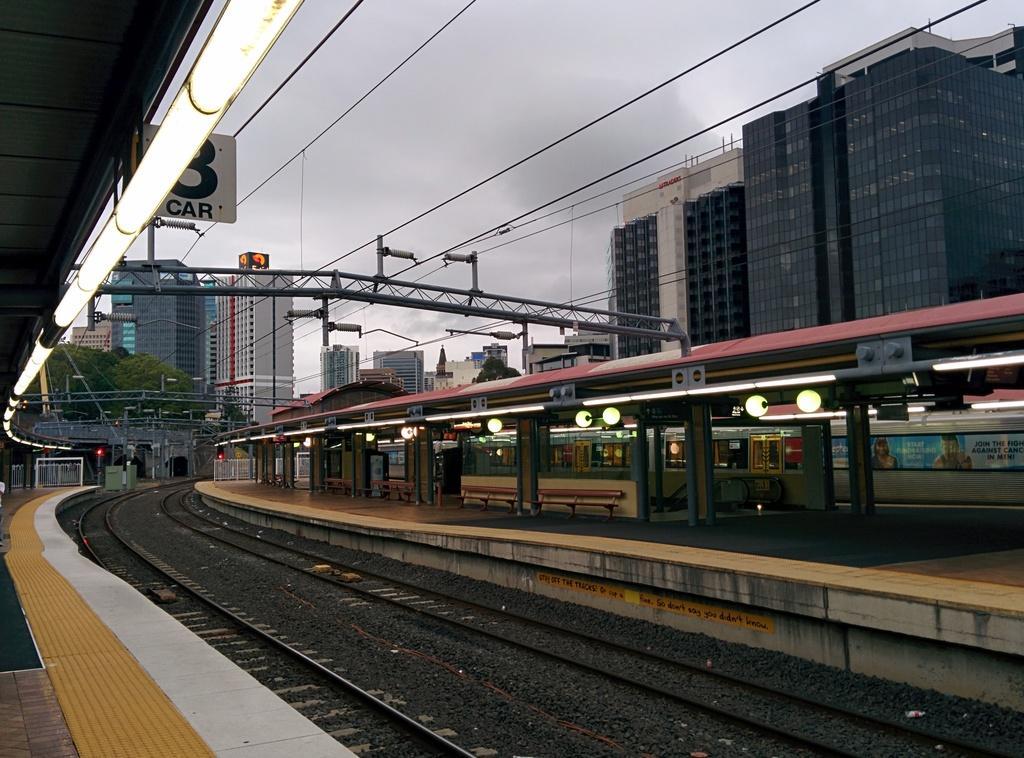Can you describe this image briefly? In the foreground I can see a train on track, platform, lights, pillars, benches, boards, wires and metal rods. In the background I can see buildings, traffic lights, trees and the sky. This image is taken may be on the platform. 